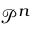Convert formula to latex. <formula><loc_0><loc_0><loc_500><loc_500>{ \mathcal { P } ^ { n } }</formula> 